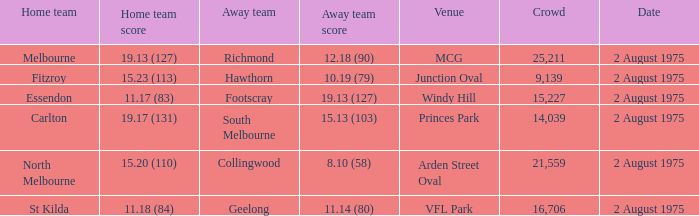How many people attended the game at VFL Park? 16706.0. 